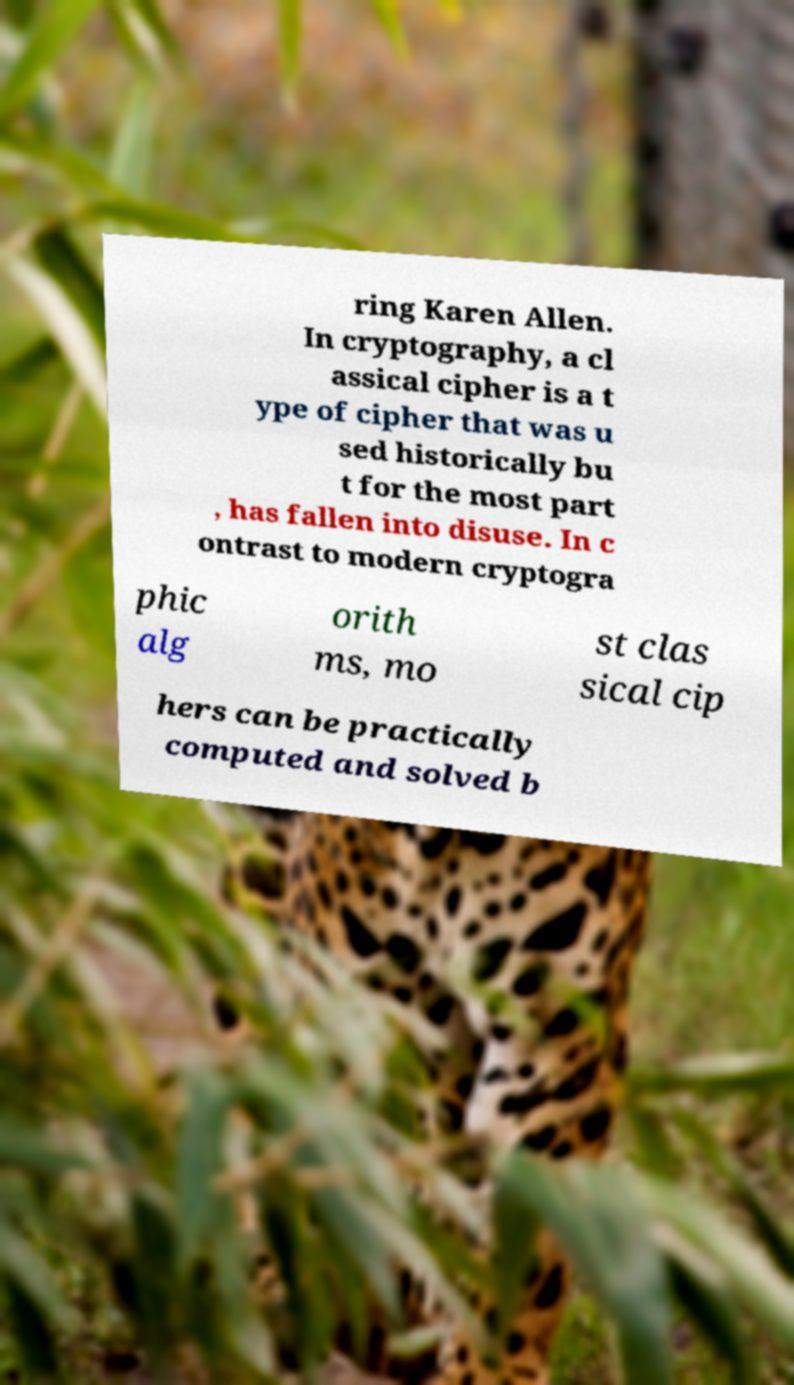There's text embedded in this image that I need extracted. Can you transcribe it verbatim? ring Karen Allen. In cryptography, a cl assical cipher is a t ype of cipher that was u sed historically bu t for the most part , has fallen into disuse. In c ontrast to modern cryptogra phic alg orith ms, mo st clas sical cip hers can be practically computed and solved b 